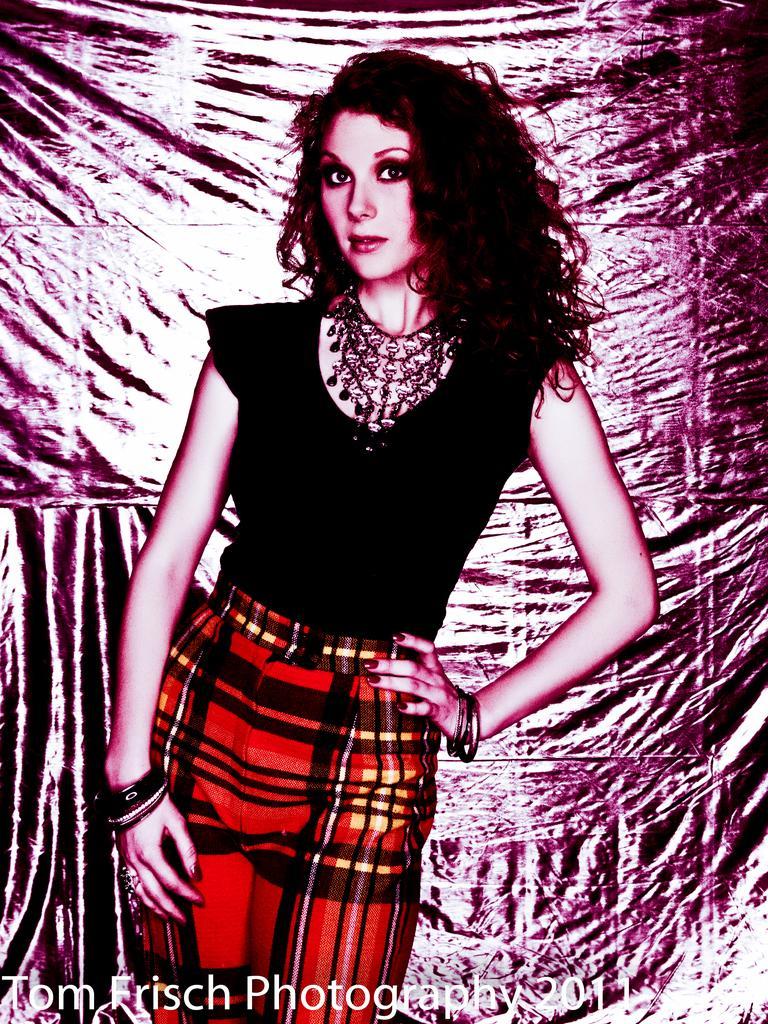Please provide a concise description of this image. In this image I can see the edited picture in which I can see a person wearing red and black colored dress is standing. I can see something is written to the bottom of the image. 